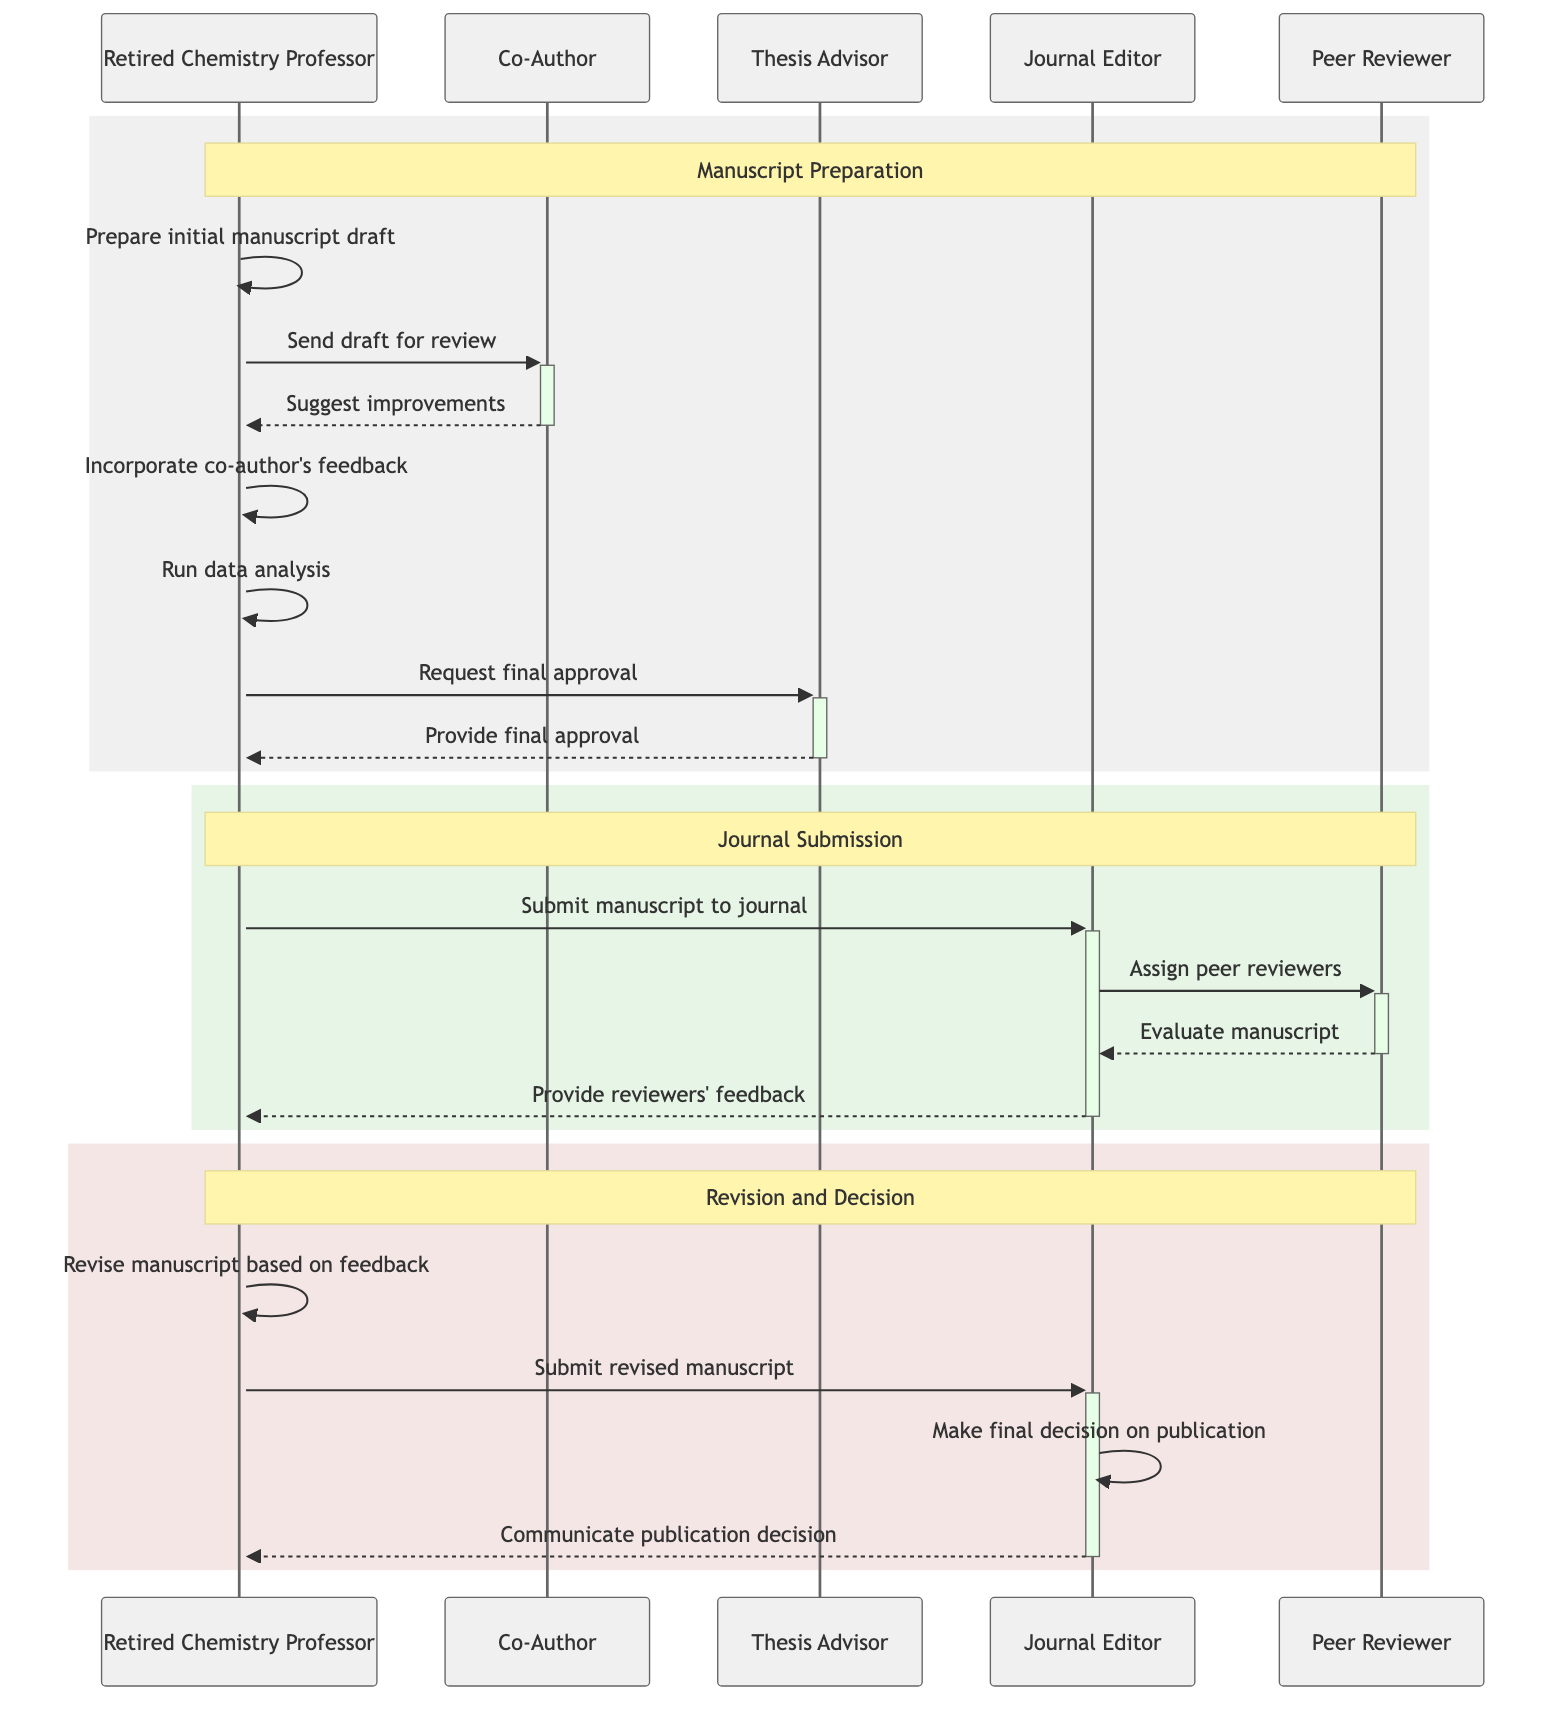What is the first action taken by the Retired Chemistry Professor? The diagram shows the Retired Chemistry Professor preparing the initial manuscript draft as the first action. This is the first arrow pointing from the Retired Chemistry Professor to himself, indicating the action.
Answer: Prepare initial manuscript draft How many actors are involved in the manuscript preparation process? By counting the distinct participants in the diagram, we see there are five actors: Retired Chemistry Professor, Co-Author, Thesis Advisor, Journal Editor, and Peer Reviewer.
Answer: Five What does the Co-Author do in the process? The Co-Author reviews the manuscript draft and suggests improvements. This is indicated by an arrow and the label in the interaction with the Retired Chemistry Professor.
Answer: Review and suggest improvements What action occurs after the Retired Chemistry Professor submits the manuscript to the journal? After submitting, the Journal Editor assigns peer reviewers. This is shown by the interaction between the Journal Editor and Peer Reviewer immediately following the submission action.
Answer: Assign peer reviewers Which document does the Retired Chemistry Professor use to revise the manuscript? The Retired Chemistry Professor creates a Revision Document after receiving feedback from the Journal Editor, as indicated in the revision process section of the diagram.
Answer: Revision Document What is the final action taken by the Journal Editor? The Journal Editor makes the final decision on publication, which is the last action noted in the diagram before the communication of the decision back to the Retired Chemistry Professor.
Answer: Make final decision on publication Which actor provides feedback to the authors? The Journal Editor provides the reviewers' feedback back to the authors. This is indicated by the action in the flow from the Journal Editor to the Retired Chemistry Professor.
Answer: Journal Editor In which step does the Retired Chemistry Professor run data analysis? The Retired Chemistry Professor runs the data analysis after incorporating feedback from the Co-Author. This is shown in the sequence of actions within the manuscript preparation phase.
Answer: Run data analysis 